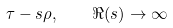<formula> <loc_0><loc_0><loc_500><loc_500>\tau - s \rho , \quad \Re ( s ) \to \infty</formula> 